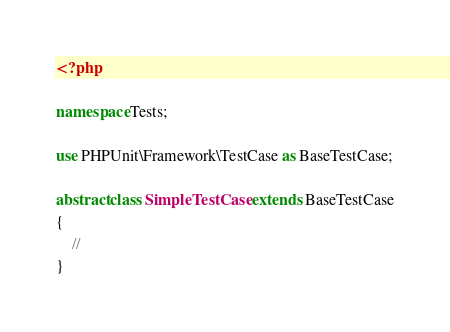Convert code to text. <code><loc_0><loc_0><loc_500><loc_500><_PHP_><?php

namespace Tests;

use PHPUnit\Framework\TestCase as BaseTestCase;

abstract class SimpleTestCase extends BaseTestCase
{
    //
}
</code> 